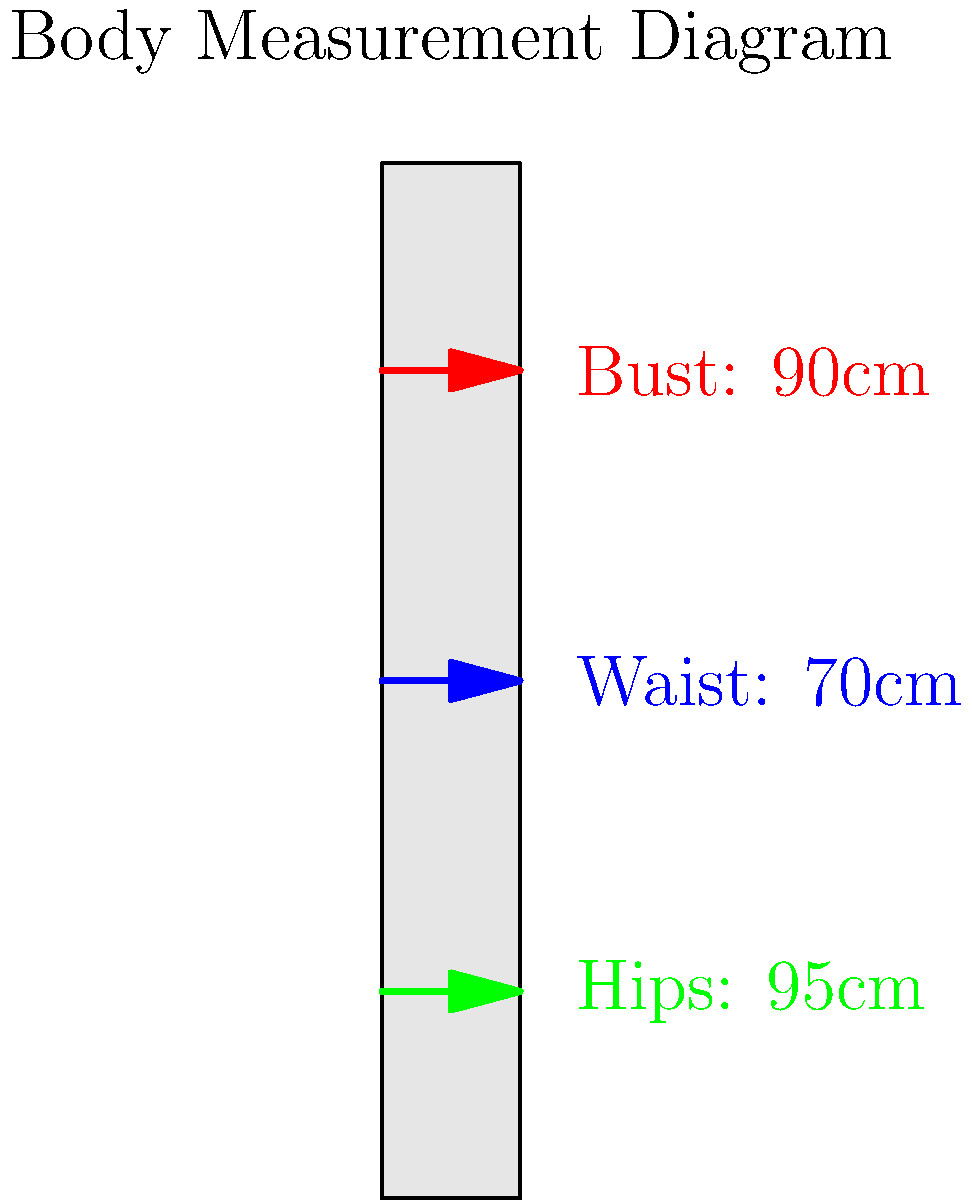As a seamstress in the union, you're tasked with predicting garment sizes based on body measurements. Given the diagram showing bust, waist, and hip measurements, which size category would you recommend for a dress, assuming the following size chart:

Size S: Bust 80-85cm, Waist 60-65cm, Hips 85-90cm
Size M: Bust 86-91cm, Waist 66-71cm, Hips 91-96cm
Size L: Bust 92-97cm, Waist 72-77cm, Hips 97-102cm

How would you document this decision-making process in your diary to help fellow union members understand size prediction? To determine the appropriate size category for the dress based on the given measurements and size chart, let's follow these steps:

1. Analyze the measurements from the diagram:
   Bust: 90cm
   Waist: 70cm
   Hips: 95cm

2. Compare each measurement to the size chart:

   Bust (90cm):
   - Too large for Size S (80-85cm)
   - Falls within Size M range (86-91cm)
   - Too small for Size L (92-97cm)

   Waist (70cm):
   - Too large for Size S (60-65cm)
   - Falls within Size M range (66-71cm)
   - Too small for Size L (72-77cm)

   Hips (95cm):
   - Too large for Size S (85-90cm)
   - Falls within Size M range (91-96cm)
   - Too small for Size L (97-102cm)

3. Determine the best fit:
   All three measurements (bust, waist, and hips) fall within the Size M range.

4. Document the process:
   In your diary, you would explain that you compared each measurement to the size chart ranges. You'd note that all three measurements consistently fell within the Size M category, making it the clear choice for this set of measurements.

5. Provide additional insights:
   You might add that when measurements fall across different size categories, it's often best to choose based on the largest measurement and consider alterations for a better fit. In this case, no such compromise was necessary.
Answer: Size M 